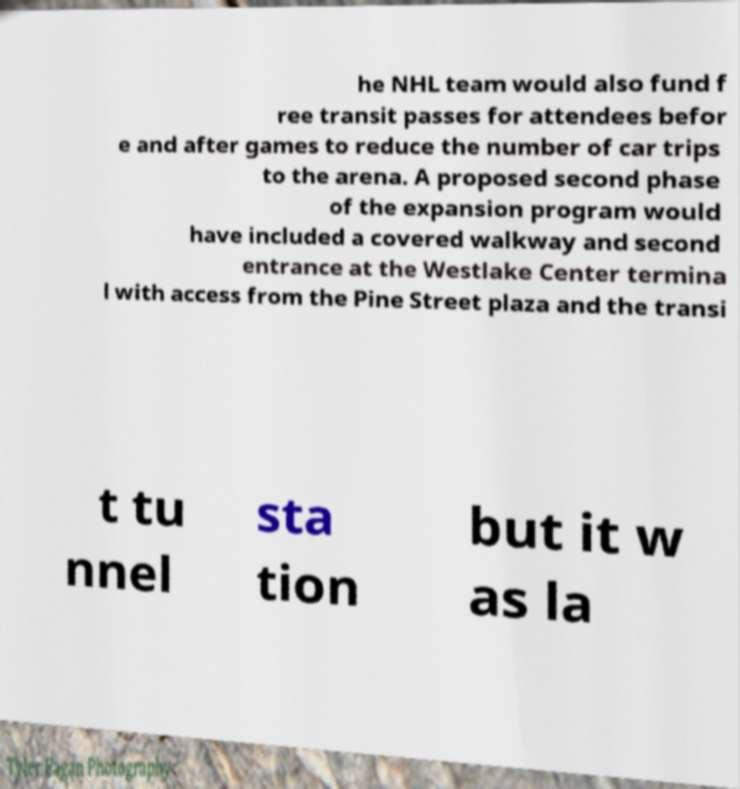For documentation purposes, I need the text within this image transcribed. Could you provide that? he NHL team would also fund f ree transit passes for attendees befor e and after games to reduce the number of car trips to the arena. A proposed second phase of the expansion program would have included a covered walkway and second entrance at the Westlake Center termina l with access from the Pine Street plaza and the transi t tu nnel sta tion but it w as la 